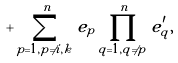Convert formula to latex. <formula><loc_0><loc_0><loc_500><loc_500>+ \sum _ { p = 1 , p \ne i , k } ^ { n } e _ { p } \prod _ { q = 1 , q \ne p } ^ { n } e _ { q } ^ { \prime } ,</formula> 